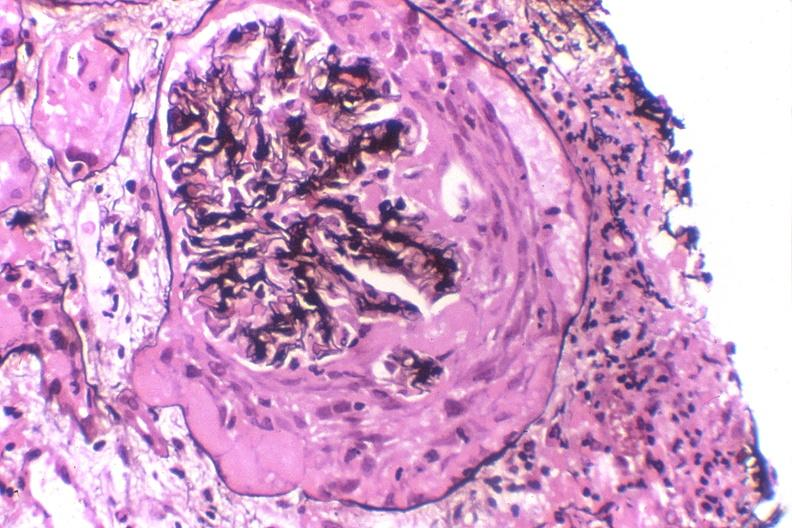do silver stain?
Answer the question using a single word or phrase. Yes 